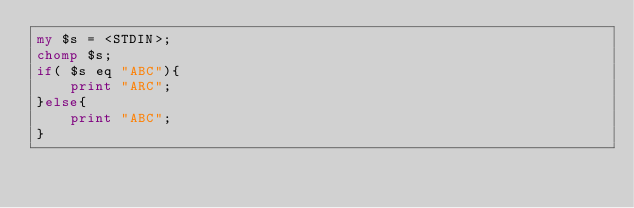Convert code to text. <code><loc_0><loc_0><loc_500><loc_500><_Perl_>my $s = <STDIN>;
chomp $s;
if( $s eq "ABC"){
    print "ARC";
}else{
    print "ABC";
}</code> 